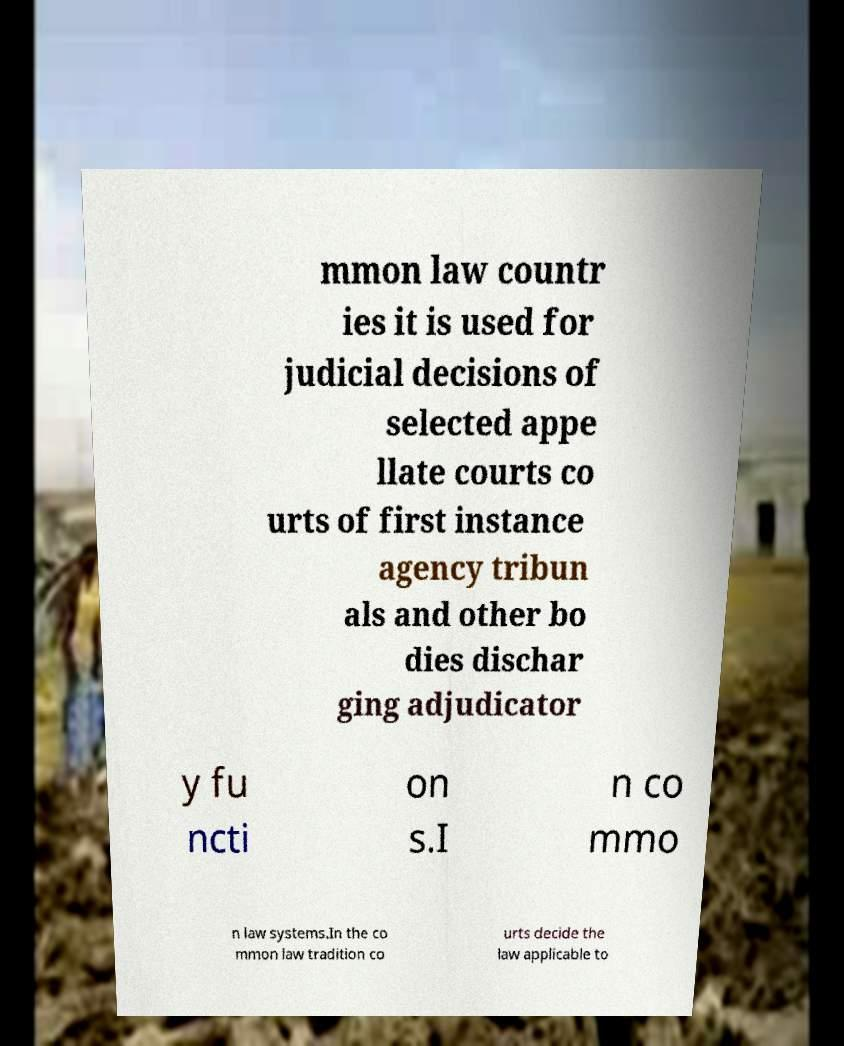For documentation purposes, I need the text within this image transcribed. Could you provide that? mmon law countr ies it is used for judicial decisions of selected appe llate courts co urts of first instance agency tribun als and other bo dies dischar ging adjudicator y fu ncti on s.I n co mmo n law systems.In the co mmon law tradition co urts decide the law applicable to 